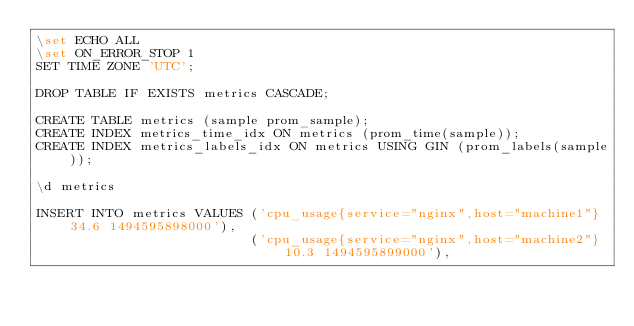Convert code to text. <code><loc_0><loc_0><loc_500><loc_500><_SQL_>\set ECHO ALL
\set ON_ERROR_STOP 1
SET TIME ZONE 'UTC';

DROP TABLE IF EXISTS metrics CASCADE;

CREATE TABLE metrics (sample prom_sample);
CREATE INDEX metrics_time_idx ON metrics (prom_time(sample));
CREATE INDEX metrics_labels_idx ON metrics USING GIN (prom_labels(sample));

\d metrics

INSERT INTO metrics VALUES ('cpu_usage{service="nginx",host="machine1"} 34.6 1494595898000'),
                           ('cpu_usage{service="nginx",host="machine2"} 10.3 1494595899000'),</code> 